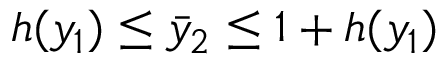Convert formula to latex. <formula><loc_0><loc_0><loc_500><loc_500>h ( y _ { 1 } ) \leq \bar { y } _ { 2 } \leq 1 + h ( y _ { 1 } )</formula> 